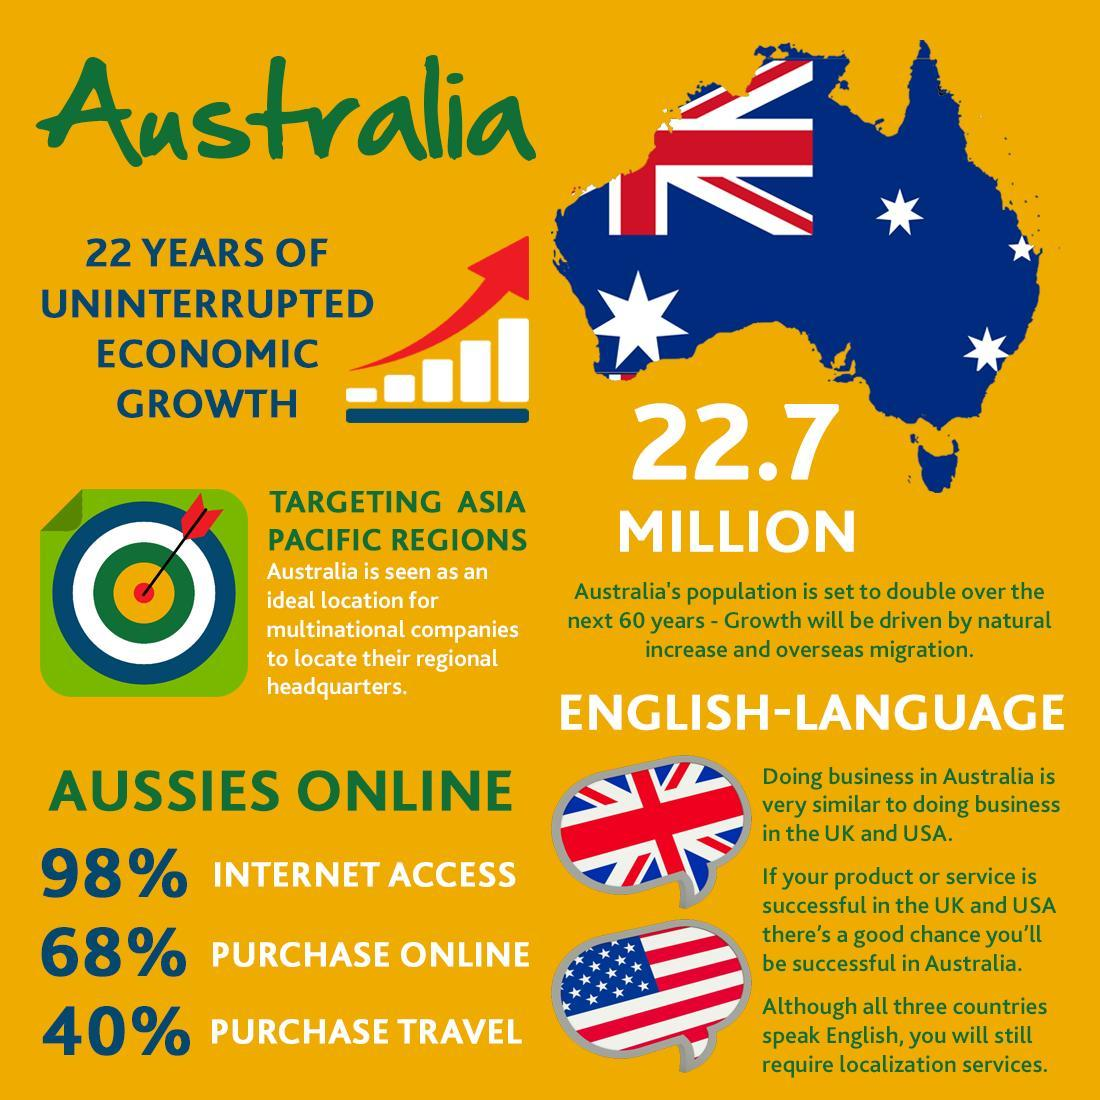What percentage of Australians do not purchase through online?
Answer the question with a short phrase. 32 What percent of Australians does not use Internet? 2% What percentage of Australians do not purchase or travel? 60 What is the population of Australia? 22.7 million 